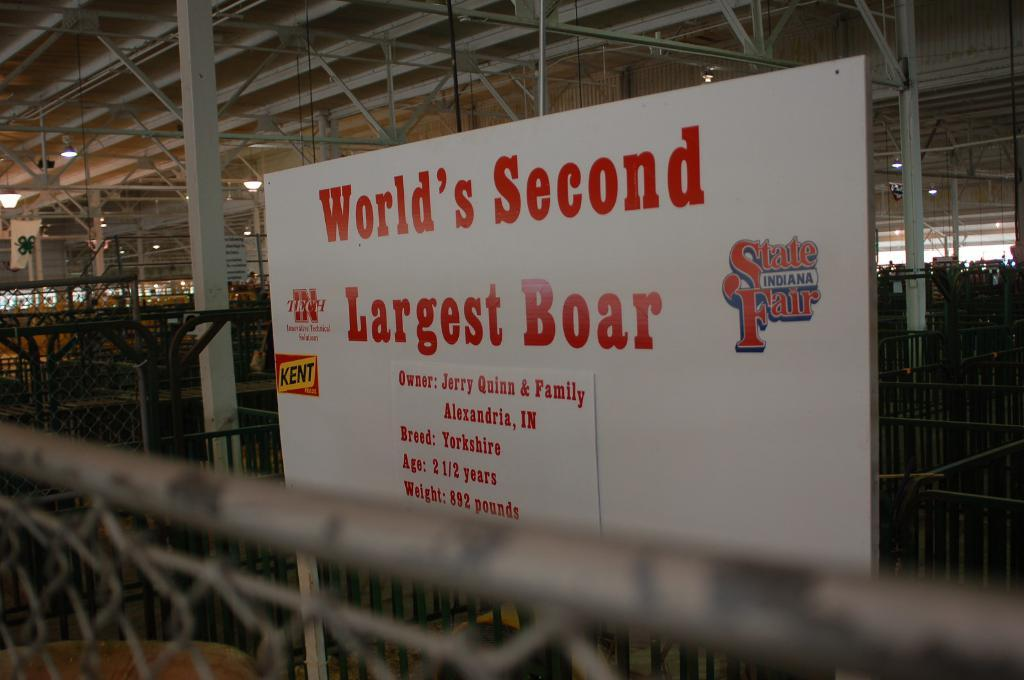<image>
Give a short and clear explanation of the subsequent image. a sign claiming to have the World's Second Largest Boar 